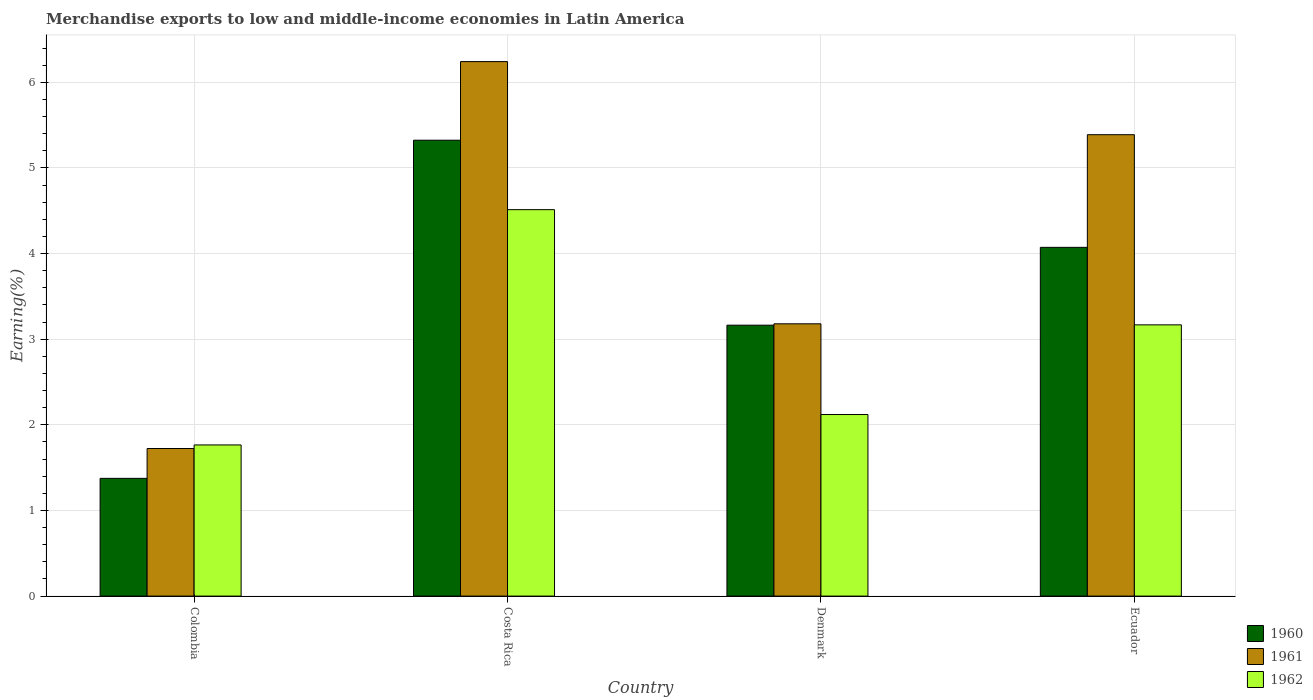How many different coloured bars are there?
Provide a succinct answer. 3. How many groups of bars are there?
Your answer should be very brief. 4. Are the number of bars per tick equal to the number of legend labels?
Your response must be concise. Yes. How many bars are there on the 1st tick from the left?
Ensure brevity in your answer.  3. What is the label of the 2nd group of bars from the left?
Offer a very short reply. Costa Rica. What is the percentage of amount earned from merchandise exports in 1960 in Denmark?
Your response must be concise. 3.16. Across all countries, what is the maximum percentage of amount earned from merchandise exports in 1962?
Make the answer very short. 4.51. Across all countries, what is the minimum percentage of amount earned from merchandise exports in 1961?
Give a very brief answer. 1.72. In which country was the percentage of amount earned from merchandise exports in 1960 maximum?
Your response must be concise. Costa Rica. What is the total percentage of amount earned from merchandise exports in 1960 in the graph?
Provide a short and direct response. 13.94. What is the difference between the percentage of amount earned from merchandise exports in 1961 in Denmark and that in Ecuador?
Offer a very short reply. -2.21. What is the difference between the percentage of amount earned from merchandise exports in 1961 in Colombia and the percentage of amount earned from merchandise exports in 1960 in Denmark?
Provide a succinct answer. -1.44. What is the average percentage of amount earned from merchandise exports in 1960 per country?
Ensure brevity in your answer.  3.48. What is the difference between the percentage of amount earned from merchandise exports of/in 1962 and percentage of amount earned from merchandise exports of/in 1960 in Ecuador?
Provide a short and direct response. -0.91. In how many countries, is the percentage of amount earned from merchandise exports in 1962 greater than 1.4 %?
Your response must be concise. 4. What is the ratio of the percentage of amount earned from merchandise exports in 1962 in Denmark to that in Ecuador?
Offer a terse response. 0.67. Is the difference between the percentage of amount earned from merchandise exports in 1962 in Denmark and Ecuador greater than the difference between the percentage of amount earned from merchandise exports in 1960 in Denmark and Ecuador?
Offer a very short reply. No. What is the difference between the highest and the second highest percentage of amount earned from merchandise exports in 1960?
Keep it short and to the point. -0.91. What is the difference between the highest and the lowest percentage of amount earned from merchandise exports in 1960?
Provide a short and direct response. 3.95. What does the 3rd bar from the left in Ecuador represents?
Offer a very short reply. 1962. What does the 2nd bar from the right in Denmark represents?
Your answer should be compact. 1961. How many bars are there?
Provide a short and direct response. 12. Are all the bars in the graph horizontal?
Make the answer very short. No. Are the values on the major ticks of Y-axis written in scientific E-notation?
Make the answer very short. No. Does the graph contain grids?
Offer a very short reply. Yes. Where does the legend appear in the graph?
Keep it short and to the point. Bottom right. How are the legend labels stacked?
Give a very brief answer. Vertical. What is the title of the graph?
Offer a terse response. Merchandise exports to low and middle-income economies in Latin America. Does "1995" appear as one of the legend labels in the graph?
Provide a succinct answer. No. What is the label or title of the X-axis?
Offer a very short reply. Country. What is the label or title of the Y-axis?
Provide a succinct answer. Earning(%). What is the Earning(%) of 1960 in Colombia?
Make the answer very short. 1.38. What is the Earning(%) of 1961 in Colombia?
Offer a terse response. 1.72. What is the Earning(%) in 1962 in Colombia?
Give a very brief answer. 1.77. What is the Earning(%) of 1960 in Costa Rica?
Provide a succinct answer. 5.32. What is the Earning(%) of 1961 in Costa Rica?
Offer a very short reply. 6.24. What is the Earning(%) in 1962 in Costa Rica?
Give a very brief answer. 4.51. What is the Earning(%) of 1960 in Denmark?
Provide a short and direct response. 3.16. What is the Earning(%) of 1961 in Denmark?
Keep it short and to the point. 3.18. What is the Earning(%) in 1962 in Denmark?
Ensure brevity in your answer.  2.12. What is the Earning(%) of 1960 in Ecuador?
Provide a short and direct response. 4.07. What is the Earning(%) of 1961 in Ecuador?
Your answer should be very brief. 5.39. What is the Earning(%) in 1962 in Ecuador?
Give a very brief answer. 3.17. Across all countries, what is the maximum Earning(%) in 1960?
Provide a succinct answer. 5.32. Across all countries, what is the maximum Earning(%) of 1961?
Give a very brief answer. 6.24. Across all countries, what is the maximum Earning(%) of 1962?
Keep it short and to the point. 4.51. Across all countries, what is the minimum Earning(%) of 1960?
Give a very brief answer. 1.38. Across all countries, what is the minimum Earning(%) of 1961?
Provide a short and direct response. 1.72. Across all countries, what is the minimum Earning(%) in 1962?
Provide a succinct answer. 1.77. What is the total Earning(%) in 1960 in the graph?
Provide a succinct answer. 13.94. What is the total Earning(%) in 1961 in the graph?
Offer a terse response. 16.53. What is the total Earning(%) of 1962 in the graph?
Offer a terse response. 11.57. What is the difference between the Earning(%) of 1960 in Colombia and that in Costa Rica?
Offer a very short reply. -3.95. What is the difference between the Earning(%) in 1961 in Colombia and that in Costa Rica?
Provide a short and direct response. -4.52. What is the difference between the Earning(%) in 1962 in Colombia and that in Costa Rica?
Provide a short and direct response. -2.75. What is the difference between the Earning(%) of 1960 in Colombia and that in Denmark?
Provide a short and direct response. -1.79. What is the difference between the Earning(%) of 1961 in Colombia and that in Denmark?
Give a very brief answer. -1.46. What is the difference between the Earning(%) in 1962 in Colombia and that in Denmark?
Your answer should be compact. -0.36. What is the difference between the Earning(%) in 1960 in Colombia and that in Ecuador?
Make the answer very short. -2.7. What is the difference between the Earning(%) of 1961 in Colombia and that in Ecuador?
Your response must be concise. -3.66. What is the difference between the Earning(%) in 1962 in Colombia and that in Ecuador?
Keep it short and to the point. -1.4. What is the difference between the Earning(%) in 1960 in Costa Rica and that in Denmark?
Keep it short and to the point. 2.16. What is the difference between the Earning(%) in 1961 in Costa Rica and that in Denmark?
Give a very brief answer. 3.06. What is the difference between the Earning(%) in 1962 in Costa Rica and that in Denmark?
Keep it short and to the point. 2.39. What is the difference between the Earning(%) of 1960 in Costa Rica and that in Ecuador?
Your response must be concise. 1.25. What is the difference between the Earning(%) of 1961 in Costa Rica and that in Ecuador?
Your response must be concise. 0.85. What is the difference between the Earning(%) in 1962 in Costa Rica and that in Ecuador?
Offer a very short reply. 1.35. What is the difference between the Earning(%) in 1960 in Denmark and that in Ecuador?
Offer a terse response. -0.91. What is the difference between the Earning(%) in 1961 in Denmark and that in Ecuador?
Ensure brevity in your answer.  -2.21. What is the difference between the Earning(%) of 1962 in Denmark and that in Ecuador?
Provide a succinct answer. -1.05. What is the difference between the Earning(%) of 1960 in Colombia and the Earning(%) of 1961 in Costa Rica?
Ensure brevity in your answer.  -4.87. What is the difference between the Earning(%) of 1960 in Colombia and the Earning(%) of 1962 in Costa Rica?
Provide a short and direct response. -3.14. What is the difference between the Earning(%) of 1961 in Colombia and the Earning(%) of 1962 in Costa Rica?
Offer a very short reply. -2.79. What is the difference between the Earning(%) in 1960 in Colombia and the Earning(%) in 1961 in Denmark?
Give a very brief answer. -1.8. What is the difference between the Earning(%) in 1960 in Colombia and the Earning(%) in 1962 in Denmark?
Keep it short and to the point. -0.75. What is the difference between the Earning(%) in 1961 in Colombia and the Earning(%) in 1962 in Denmark?
Offer a terse response. -0.4. What is the difference between the Earning(%) in 1960 in Colombia and the Earning(%) in 1961 in Ecuador?
Offer a very short reply. -4.01. What is the difference between the Earning(%) of 1960 in Colombia and the Earning(%) of 1962 in Ecuador?
Your answer should be compact. -1.79. What is the difference between the Earning(%) of 1961 in Colombia and the Earning(%) of 1962 in Ecuador?
Ensure brevity in your answer.  -1.44. What is the difference between the Earning(%) of 1960 in Costa Rica and the Earning(%) of 1961 in Denmark?
Provide a short and direct response. 2.14. What is the difference between the Earning(%) of 1960 in Costa Rica and the Earning(%) of 1962 in Denmark?
Make the answer very short. 3.2. What is the difference between the Earning(%) of 1961 in Costa Rica and the Earning(%) of 1962 in Denmark?
Ensure brevity in your answer.  4.12. What is the difference between the Earning(%) in 1960 in Costa Rica and the Earning(%) in 1961 in Ecuador?
Ensure brevity in your answer.  -0.06. What is the difference between the Earning(%) of 1960 in Costa Rica and the Earning(%) of 1962 in Ecuador?
Give a very brief answer. 2.16. What is the difference between the Earning(%) of 1961 in Costa Rica and the Earning(%) of 1962 in Ecuador?
Make the answer very short. 3.07. What is the difference between the Earning(%) in 1960 in Denmark and the Earning(%) in 1961 in Ecuador?
Give a very brief answer. -2.22. What is the difference between the Earning(%) in 1960 in Denmark and the Earning(%) in 1962 in Ecuador?
Offer a very short reply. -0. What is the difference between the Earning(%) of 1961 in Denmark and the Earning(%) of 1962 in Ecuador?
Ensure brevity in your answer.  0.01. What is the average Earning(%) of 1960 per country?
Your answer should be compact. 3.48. What is the average Earning(%) of 1961 per country?
Your answer should be compact. 4.13. What is the average Earning(%) of 1962 per country?
Your answer should be compact. 2.89. What is the difference between the Earning(%) in 1960 and Earning(%) in 1961 in Colombia?
Your response must be concise. -0.35. What is the difference between the Earning(%) in 1960 and Earning(%) in 1962 in Colombia?
Keep it short and to the point. -0.39. What is the difference between the Earning(%) in 1961 and Earning(%) in 1962 in Colombia?
Provide a short and direct response. -0.04. What is the difference between the Earning(%) in 1960 and Earning(%) in 1961 in Costa Rica?
Make the answer very short. -0.92. What is the difference between the Earning(%) in 1960 and Earning(%) in 1962 in Costa Rica?
Offer a very short reply. 0.81. What is the difference between the Earning(%) in 1961 and Earning(%) in 1962 in Costa Rica?
Keep it short and to the point. 1.73. What is the difference between the Earning(%) of 1960 and Earning(%) of 1961 in Denmark?
Offer a very short reply. -0.02. What is the difference between the Earning(%) of 1960 and Earning(%) of 1962 in Denmark?
Provide a short and direct response. 1.04. What is the difference between the Earning(%) in 1961 and Earning(%) in 1962 in Denmark?
Keep it short and to the point. 1.06. What is the difference between the Earning(%) of 1960 and Earning(%) of 1961 in Ecuador?
Your response must be concise. -1.32. What is the difference between the Earning(%) in 1960 and Earning(%) in 1962 in Ecuador?
Offer a terse response. 0.91. What is the difference between the Earning(%) of 1961 and Earning(%) of 1962 in Ecuador?
Your response must be concise. 2.22. What is the ratio of the Earning(%) of 1960 in Colombia to that in Costa Rica?
Ensure brevity in your answer.  0.26. What is the ratio of the Earning(%) in 1961 in Colombia to that in Costa Rica?
Your response must be concise. 0.28. What is the ratio of the Earning(%) in 1962 in Colombia to that in Costa Rica?
Your answer should be compact. 0.39. What is the ratio of the Earning(%) of 1960 in Colombia to that in Denmark?
Provide a succinct answer. 0.43. What is the ratio of the Earning(%) of 1961 in Colombia to that in Denmark?
Offer a very short reply. 0.54. What is the ratio of the Earning(%) of 1962 in Colombia to that in Denmark?
Your answer should be compact. 0.83. What is the ratio of the Earning(%) in 1960 in Colombia to that in Ecuador?
Ensure brevity in your answer.  0.34. What is the ratio of the Earning(%) of 1961 in Colombia to that in Ecuador?
Ensure brevity in your answer.  0.32. What is the ratio of the Earning(%) of 1962 in Colombia to that in Ecuador?
Offer a very short reply. 0.56. What is the ratio of the Earning(%) in 1960 in Costa Rica to that in Denmark?
Ensure brevity in your answer.  1.68. What is the ratio of the Earning(%) of 1961 in Costa Rica to that in Denmark?
Your response must be concise. 1.96. What is the ratio of the Earning(%) in 1962 in Costa Rica to that in Denmark?
Offer a very short reply. 2.13. What is the ratio of the Earning(%) of 1960 in Costa Rica to that in Ecuador?
Ensure brevity in your answer.  1.31. What is the ratio of the Earning(%) of 1961 in Costa Rica to that in Ecuador?
Make the answer very short. 1.16. What is the ratio of the Earning(%) in 1962 in Costa Rica to that in Ecuador?
Ensure brevity in your answer.  1.42. What is the ratio of the Earning(%) of 1960 in Denmark to that in Ecuador?
Your response must be concise. 0.78. What is the ratio of the Earning(%) in 1961 in Denmark to that in Ecuador?
Offer a terse response. 0.59. What is the ratio of the Earning(%) of 1962 in Denmark to that in Ecuador?
Provide a succinct answer. 0.67. What is the difference between the highest and the second highest Earning(%) in 1960?
Your answer should be compact. 1.25. What is the difference between the highest and the second highest Earning(%) of 1961?
Ensure brevity in your answer.  0.85. What is the difference between the highest and the second highest Earning(%) in 1962?
Give a very brief answer. 1.35. What is the difference between the highest and the lowest Earning(%) in 1960?
Ensure brevity in your answer.  3.95. What is the difference between the highest and the lowest Earning(%) in 1961?
Give a very brief answer. 4.52. What is the difference between the highest and the lowest Earning(%) in 1962?
Give a very brief answer. 2.75. 